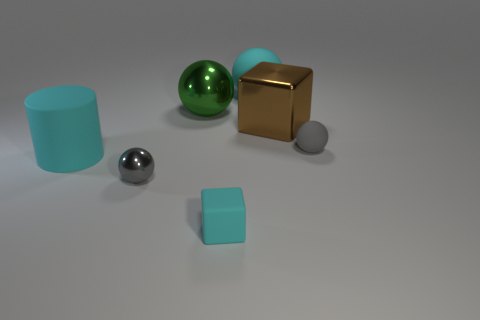Subtract all green balls. How many balls are left? 3 Subtract all brown balls. How many cyan cubes are left? 1 Add 2 green cubes. How many objects exist? 9 Subtract 0 blue cubes. How many objects are left? 7 Subtract all balls. How many objects are left? 3 Subtract all blue blocks. Subtract all red spheres. How many blocks are left? 2 Subtract all tiny cyan rubber objects. Subtract all big rubber spheres. How many objects are left? 5 Add 1 small spheres. How many small spheres are left? 3 Add 1 big matte cylinders. How many big matte cylinders exist? 2 